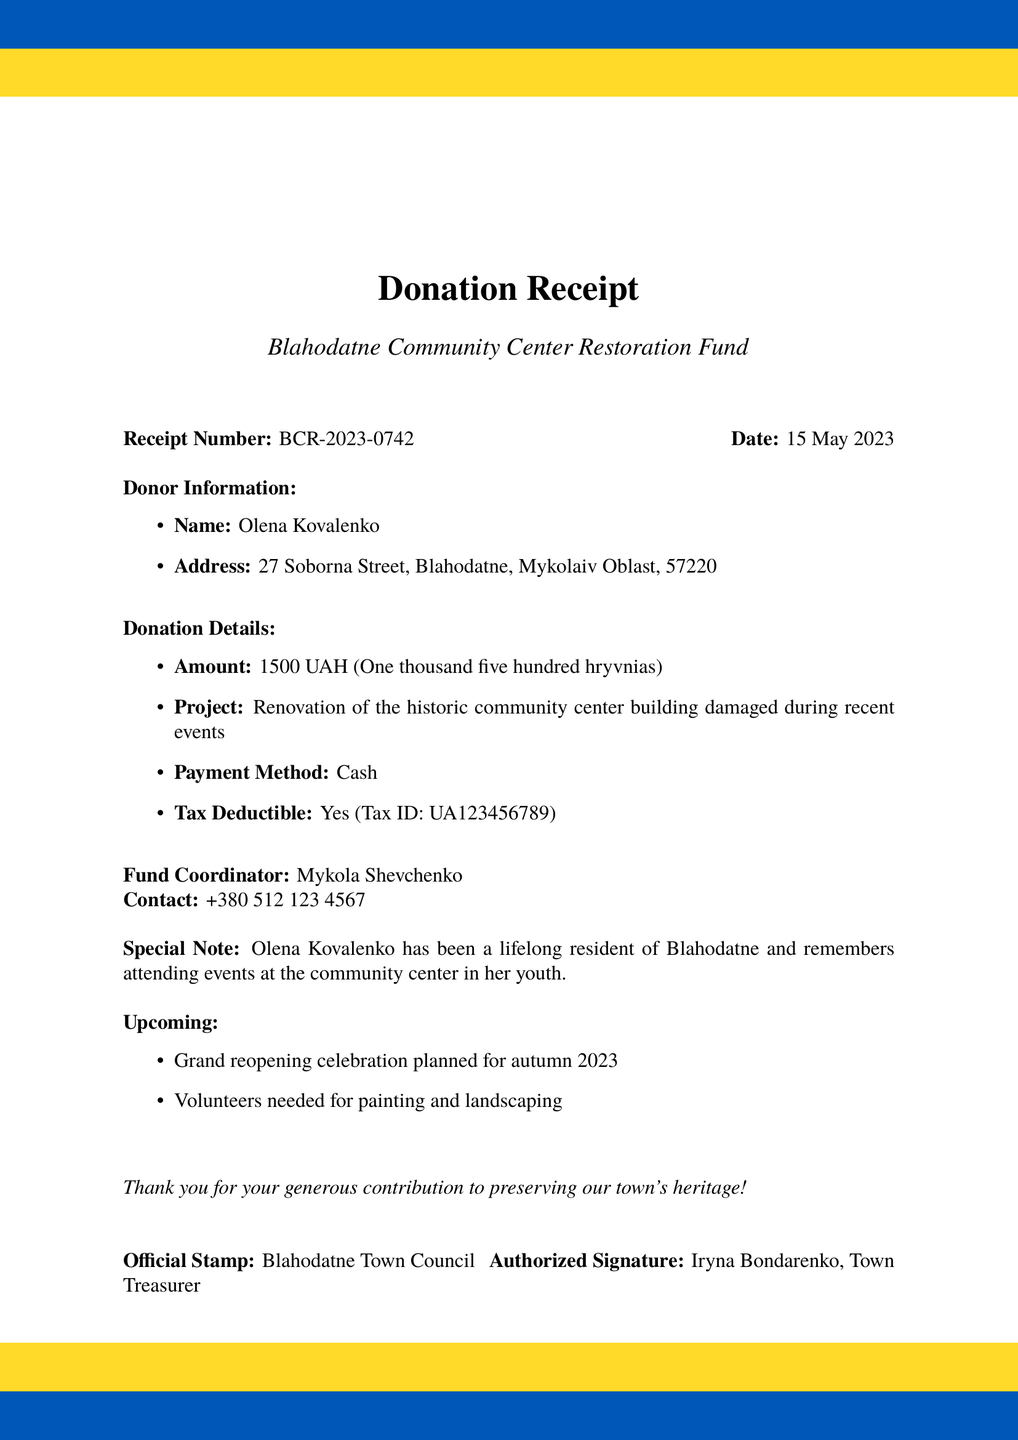What is the receipt number? The receipt number can be found in the header of the document, identifying the specific donation made.
Answer: BCR-2023-0742 Who is the donor? The donor's name is mentioned prominently in the donor information section of the receipt.
Answer: Olena Kovalenko What is the donation amount in words? The document specifies the donation amount in both numerical and word formats.
Answer: One thousand five hundred hryvnias What is the project name? The project name is indicated in the title section of the receipt.
Answer: Blahodatne Community Center Restoration Fund What is the special note about the donor? The special note provides a personal connection of the donor to the community center.
Answer: Olena Kovalenko has been a lifelong resident of Blahodatne and remembers attending events at the community center in her youth What is the date of the donation? The date is clearly stated in the header of the receipt, showing when the donation was made.
Answer: 15 May 2023 What is the payment method? The payment method is listed under the donation details section of the document.
Answer: Cash Who is the fund coordinator? The fund coordinator's name is provided in the receipt, linking them to the project.
Answer: Mykola Shevchenko What future event is mentioned? The receipt includes information about a future event related to the project.
Answer: Grand reopening celebration planned for autumn 2023 